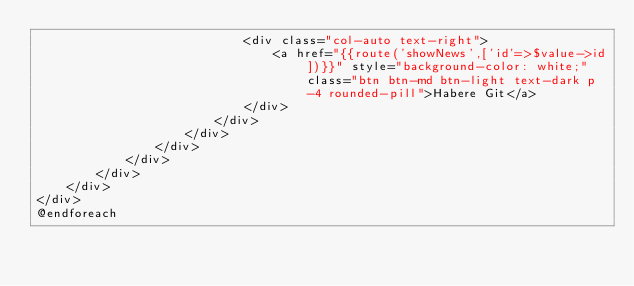Convert code to text. <code><loc_0><loc_0><loc_500><loc_500><_PHP_>                            <div class="col-auto text-right">
                                <a href="{{route('showNews',['id'=>$value->id])}}" style="background-color: white;" class="btn btn-md btn-light text-dark p-4 rounded-pill">Habere Git</a>
                            </div>
                        </div>
                    </div>
                </div>
            </div>
        </div>
    </div>
</div>
@endforeach</code> 